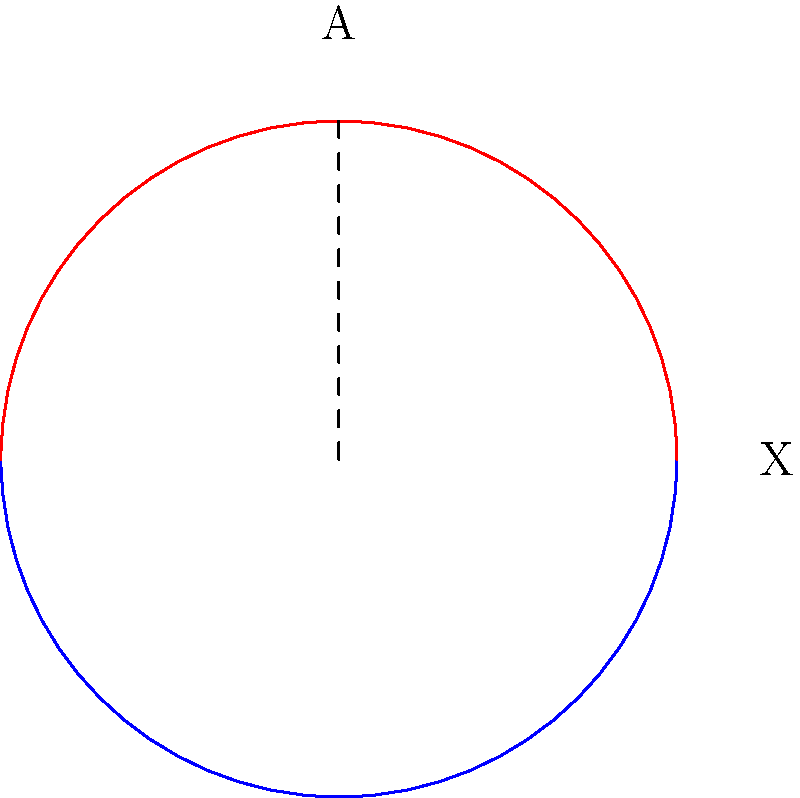Consider the topological space $X$ represented by the blue circle, with a subspace $A$ shown in red. This space symbolizes the intertwining fates of mythical beings in a dark fantasy realm. Calculate the relative homology group $H_1(X,A)$, where $X$ is homeomorphic to $S^1$ and $A$ is homeomorphic to the closed interval $[0,1]$. To calculate the relative homology group $H_1(X,A)$, we'll follow these steps:

1) First, recall the long exact sequence of relative homology:

   $$... \to H_1(A) \to H_1(X) \to H_1(X,A) \to H_0(A) \to H_0(X) \to H_0(X,A) \to 0$$

2) We know:
   - $X \cong S^1$, so $H_1(X) \cong \mathbb{Z}$ and $H_0(X) \cong \mathbb{Z}$
   - $A \cong [0,1]$, so $H_1(A) \cong 0$ and $H_0(A) \cong \mathbb{Z}$

3) Substituting these into our sequence:

   $$0 \to \mathbb{Z} \to H_1(X,A) \to \mathbb{Z} \to \mathbb{Z} \to H_0(X,A) \to 0$$

4) The map $H_0(A) \to H_0(X)$ is an isomorphism, so $H_0(X,A) \cong 0$

5) This means the map $\mathbb{Z} \to \mathbb{Z}$ in our sequence is an isomorphism

6) By exactness, this implies that $H_1(X,A) \cong \mathbb{Z}$

Therefore, the relative homology group $H_1(X,A)$ is isomorphic to $\mathbb{Z}$.
Answer: $H_1(X,A) \cong \mathbb{Z}$ 